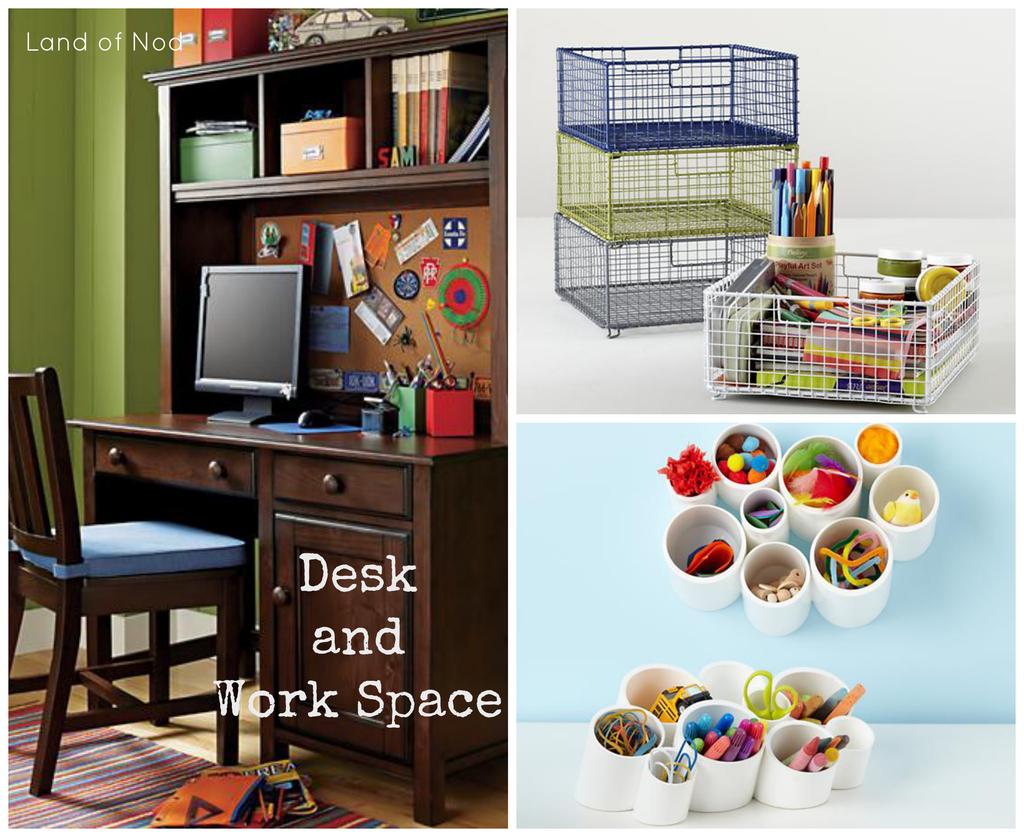What company is this from?
Ensure brevity in your answer.  Land of nod. What area is the ad focused on?
Provide a short and direct response. Desk and work space. 